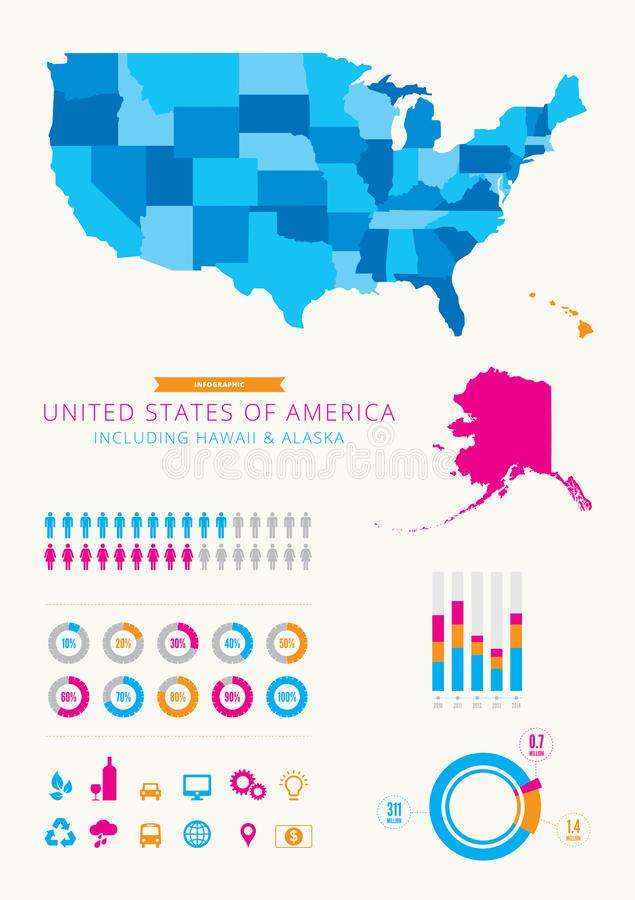Mention a couple of crucial points in this snapshot. In the provided infographic, nine women are depicted in magenta. The colors yellow, magenta, blue, and green represent Alaska on the map. In the year 2010, the population of Alaska was at its highest. In the given infographic, 11 men are depicted as being colored in blue. Hawaii is depicted in a map in colors of red, orange, green, and blue, with orange as the predominant color. 